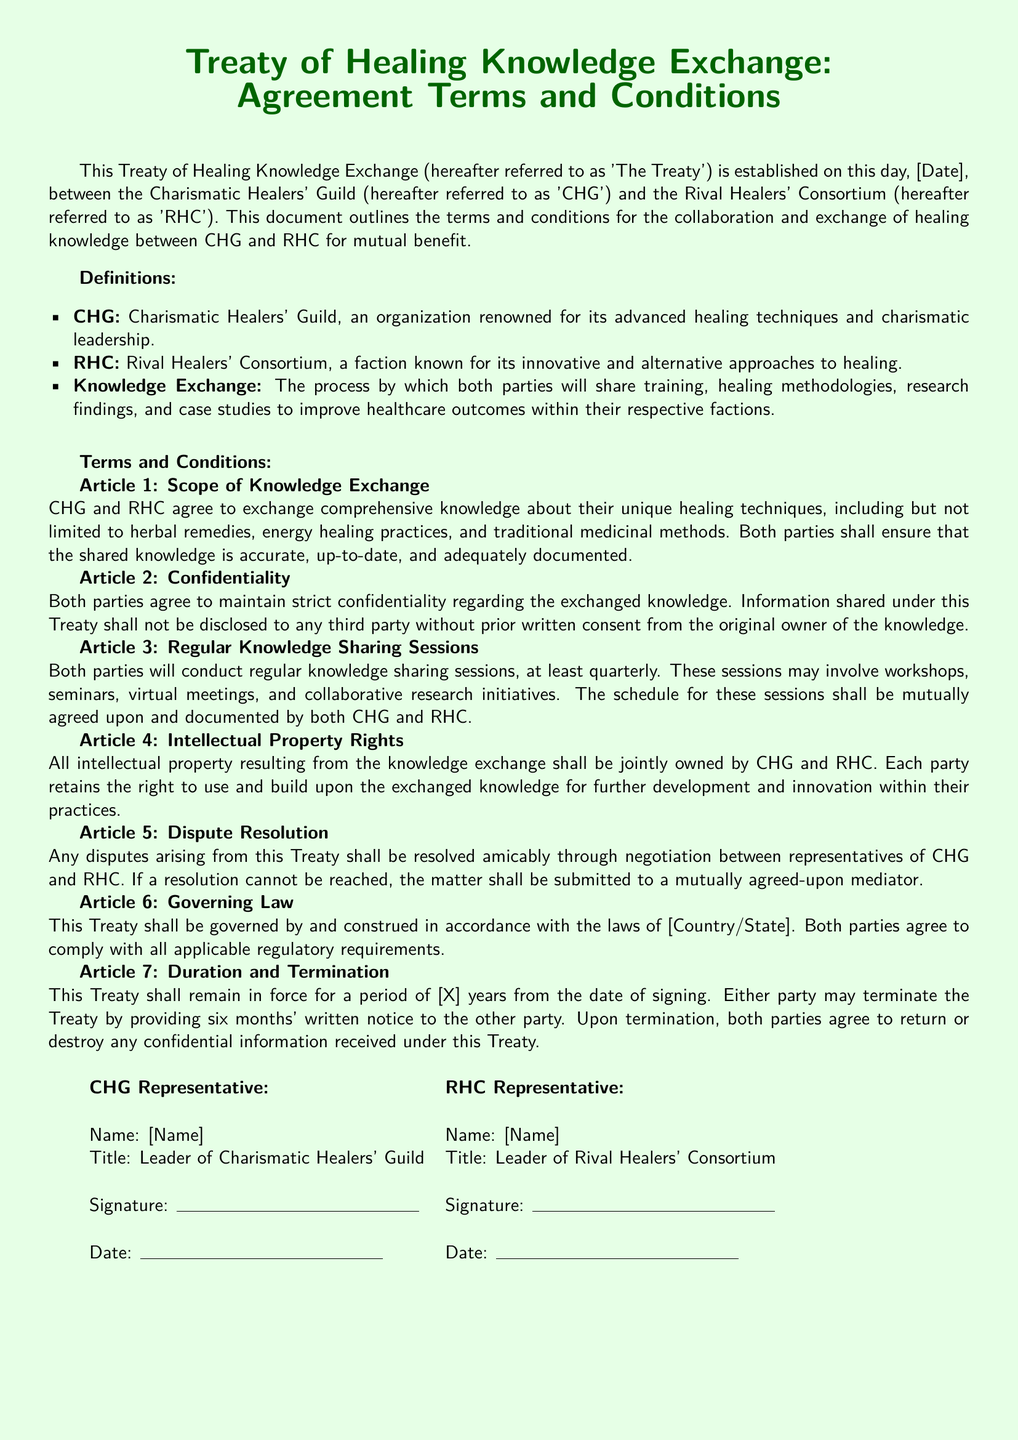What is the title of the document? The title is the main heading of the document, indicating its purpose, which is the agreement on knowledge exchange.
Answer: Treaty of Healing Knowledge Exchange What does CHG stand for? CHG is the acronym used in the document for the Charismatic Healers' Guild, as defined in the document.
Answer: Charismatic Healers' Guild Who is responsible for conflict resolution? The document specifies how disputes should be handled, indicating the parties involved in this process.
Answer: Representatives of CHG and RHC How often will knowledge sharing sessions be conducted? The document outlines the frequency of knowledge sharing sessions agreed upon by both parties.
Answer: At least quarterly What is the duration of the Treaty? The document mentions a specific timeframe for how long the Treaty will be in effect, indicated by the placeholder.
Answer: [X] years What is required for information to be shared with third parties? The document sets a condition regarding the sharing of information, relating to consent from the original owner.
Answer: Prior written consent What will happen to confidential information upon termination? The document specifies the actions to be taken regarding confidential information following the termination of the Treaty.
Answer: Return or destroy What will be jointly owned according to Article 4? The document specifies a particular type of property that both parties retain rights over.
Answer: Intellectual property resulting from the knowledge exchange 